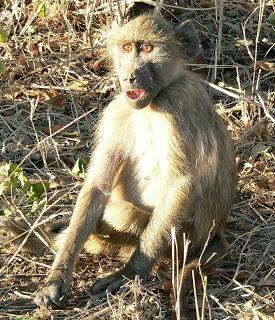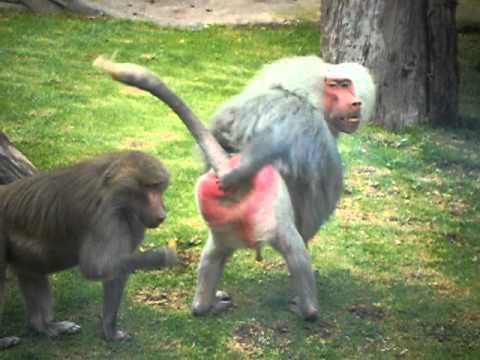The first image is the image on the left, the second image is the image on the right. Assess this claim about the two images: "The left image contains exactly one primate.". Correct or not? Answer yes or no. Yes. The first image is the image on the left, the second image is the image on the right. Considering the images on both sides, is "there are three monkeys in the image to the right." valid? Answer yes or no. No. 